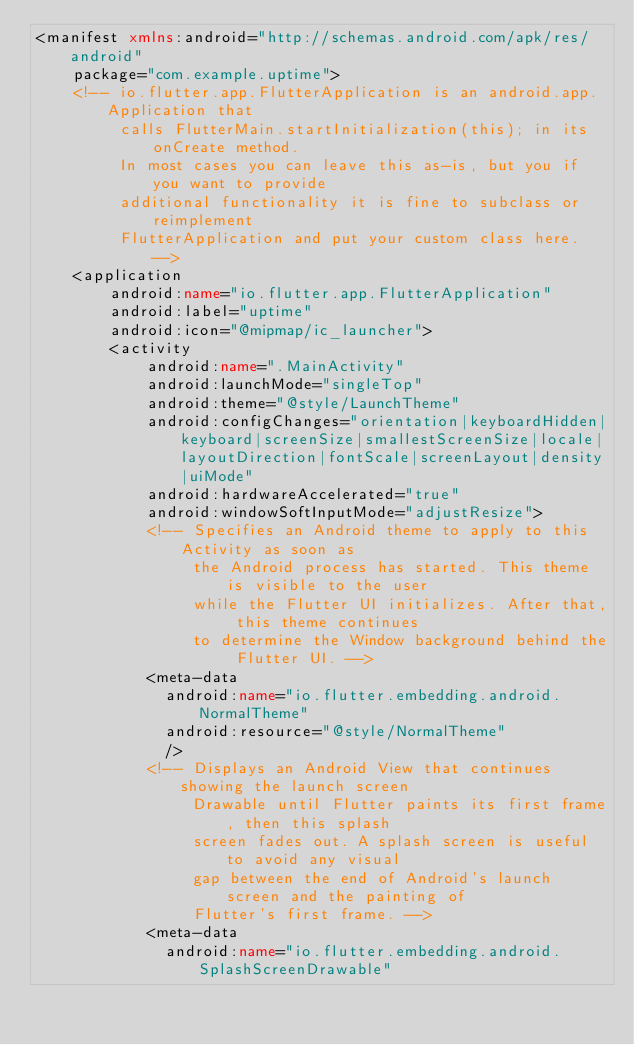<code> <loc_0><loc_0><loc_500><loc_500><_XML_><manifest xmlns:android="http://schemas.android.com/apk/res/android"
    package="com.example.uptime">
    <!-- io.flutter.app.FlutterApplication is an android.app.Application that
         calls FlutterMain.startInitialization(this); in its onCreate method.
         In most cases you can leave this as-is, but you if you want to provide
         additional functionality it is fine to subclass or reimplement
         FlutterApplication and put your custom class here. -->
    <application
        android:name="io.flutter.app.FlutterApplication"
        android:label="uptime"
        android:icon="@mipmap/ic_launcher">
        <activity
            android:name=".MainActivity"
            android:launchMode="singleTop"
            android:theme="@style/LaunchTheme"
            android:configChanges="orientation|keyboardHidden|keyboard|screenSize|smallestScreenSize|locale|layoutDirection|fontScale|screenLayout|density|uiMode"
            android:hardwareAccelerated="true"
            android:windowSoftInputMode="adjustResize">
            <!-- Specifies an Android theme to apply to this Activity as soon as
                 the Android process has started. This theme is visible to the user
                 while the Flutter UI initializes. After that, this theme continues
                 to determine the Window background behind the Flutter UI. -->
            <meta-data
              android:name="io.flutter.embedding.android.NormalTheme"
              android:resource="@style/NormalTheme"
              />
            <!-- Displays an Android View that continues showing the launch screen
                 Drawable until Flutter paints its first frame, then this splash
                 screen fades out. A splash screen is useful to avoid any visual
                 gap between the end of Android's launch screen and the painting of
                 Flutter's first frame. -->
            <meta-data
              android:name="io.flutter.embedding.android.SplashScreenDrawable"</code> 